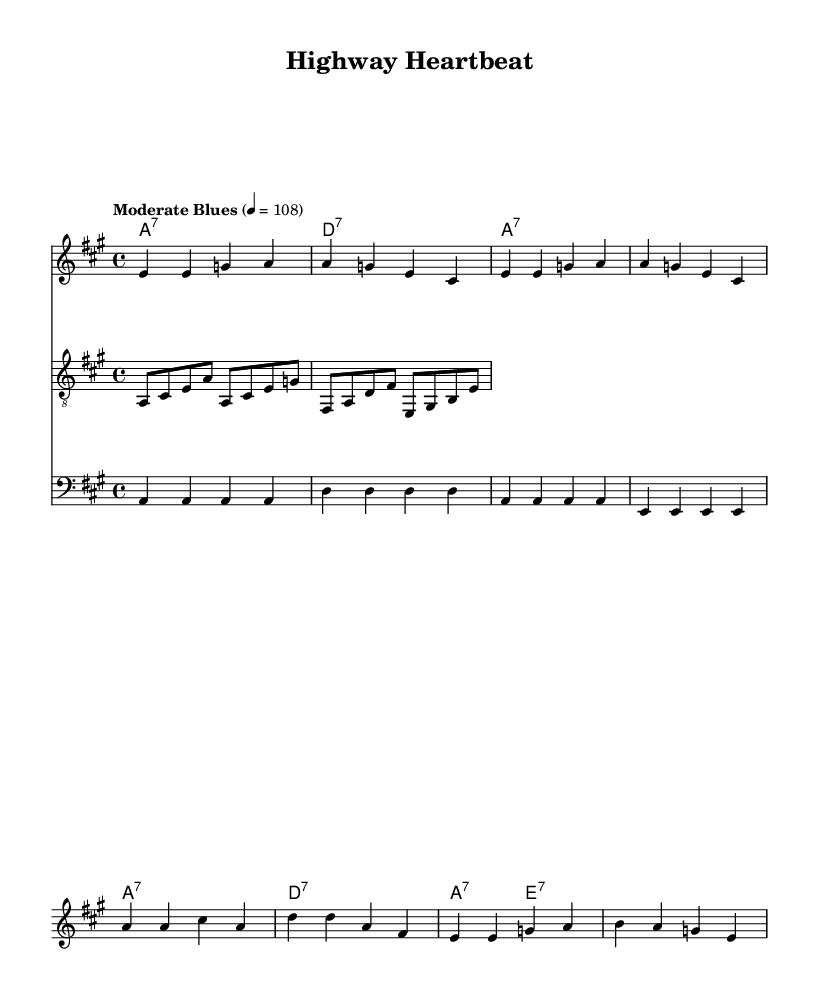What is the key signature of this music? The key signature is A major, which has three sharps (F#, C#, and G#).
Answer: A major What is the time signature of this song? The time signature is 4/4, indicating that there are four beats per measure and a quarter note gets one beat.
Answer: 4/4 What is the tempo marking for this piece? The tempo is marked as "Moderate Blues" with a metronome marking of 108 beats per minute, indicating a moderate pace typical for a blues rhythm.
Answer: Moderate Blues How many measures are in the verse section? The verse consists of four measures, as indicated by the grouping of the notes and chords labeled in the score.
Answer: Four measures What type of guitar riff is used in this piece? The guitar riff is a melodic phrase that complements the blues-rock style, utilizing classic blues notes like the root, minor third, and fifth to create a call-and-response effect.
Answer: Melodic phrase What is the primary chord progression in the verse? The chord progression in the verse is a 7th chord pattern, specifically A7 to D7, which is characteristic of blues music, creating a familiar and traditional sound.
Answer: A7 to D7 What are the first lyrics of the song? The first lyrics start with "Miles of asphalt stretching out ahead," setting the thematic tone of life on the open road.
Answer: Miles of asphalt stretching out ahead 